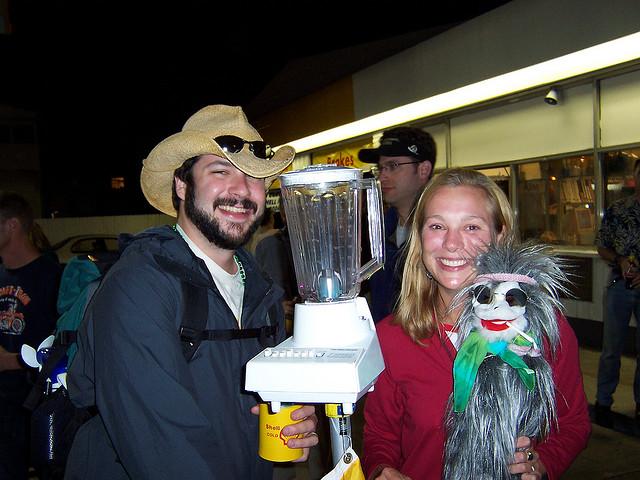What is on top of his hat?
Write a very short answer. Sunglasses. Is the man holding a blender in one of his hands?
Be succinct. Yes. Are these prizes?
Give a very brief answer. Yes. 